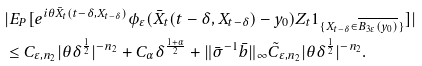Convert formula to latex. <formula><loc_0><loc_0><loc_500><loc_500>& | E _ { P } [ e ^ { i \theta \bar { X } _ { t } ( t - \delta , X _ { t - \delta } ) } \phi _ { \varepsilon } ( \bar { X } _ { t } ( t - \delta , X _ { t - \delta } ) - y _ { 0 } ) Z _ { t } 1 _ { \{ X _ { t - \delta } \in \overline { B _ { 3 \varepsilon } ( y _ { 0 } ) } \} } ] | \\ & \leq C _ { \varepsilon , n _ { 2 } } | \theta \delta ^ { \frac { 1 } { 2 } } | ^ { - n _ { 2 } } + C _ { \alpha } \delta ^ { \frac { 1 + \alpha } { 2 } } + \| \bar { \sigma } ^ { - 1 } \bar { b } \| _ { \infty } \tilde { C } _ { \varepsilon , n _ { 2 } } | \theta \delta ^ { \frac { 1 } { 2 } } | ^ { - n _ { 2 } } .</formula> 